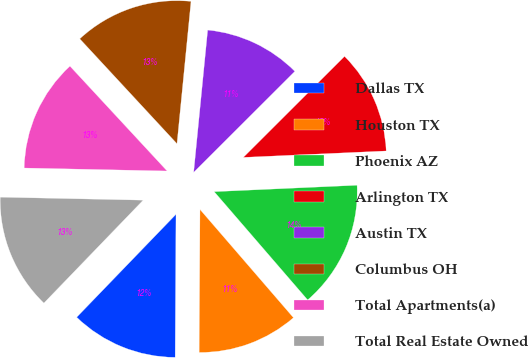Convert chart. <chart><loc_0><loc_0><loc_500><loc_500><pie_chart><fcel>Dallas TX<fcel>Houston TX<fcel>Phoenix AZ<fcel>Arlington TX<fcel>Austin TX<fcel>Columbus OH<fcel>Total Apartments(a)<fcel>Total Real Estate Owned<nl><fcel>12.12%<fcel>11.43%<fcel>14.38%<fcel>11.77%<fcel>10.95%<fcel>13.46%<fcel>12.77%<fcel>13.12%<nl></chart> 